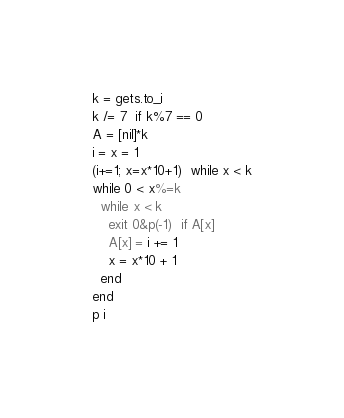<code> <loc_0><loc_0><loc_500><loc_500><_Ruby_>k = gets.to_i
k /= 7  if k%7 == 0
A = [nil]*k
i = x = 1
(i+=1; x=x*10+1)  while x < k
while 0 < x%=k
  while x < k
    exit 0&p(-1)  if A[x]
    A[x] = i += 1
    x = x*10 + 1
  end
end
p i</code> 